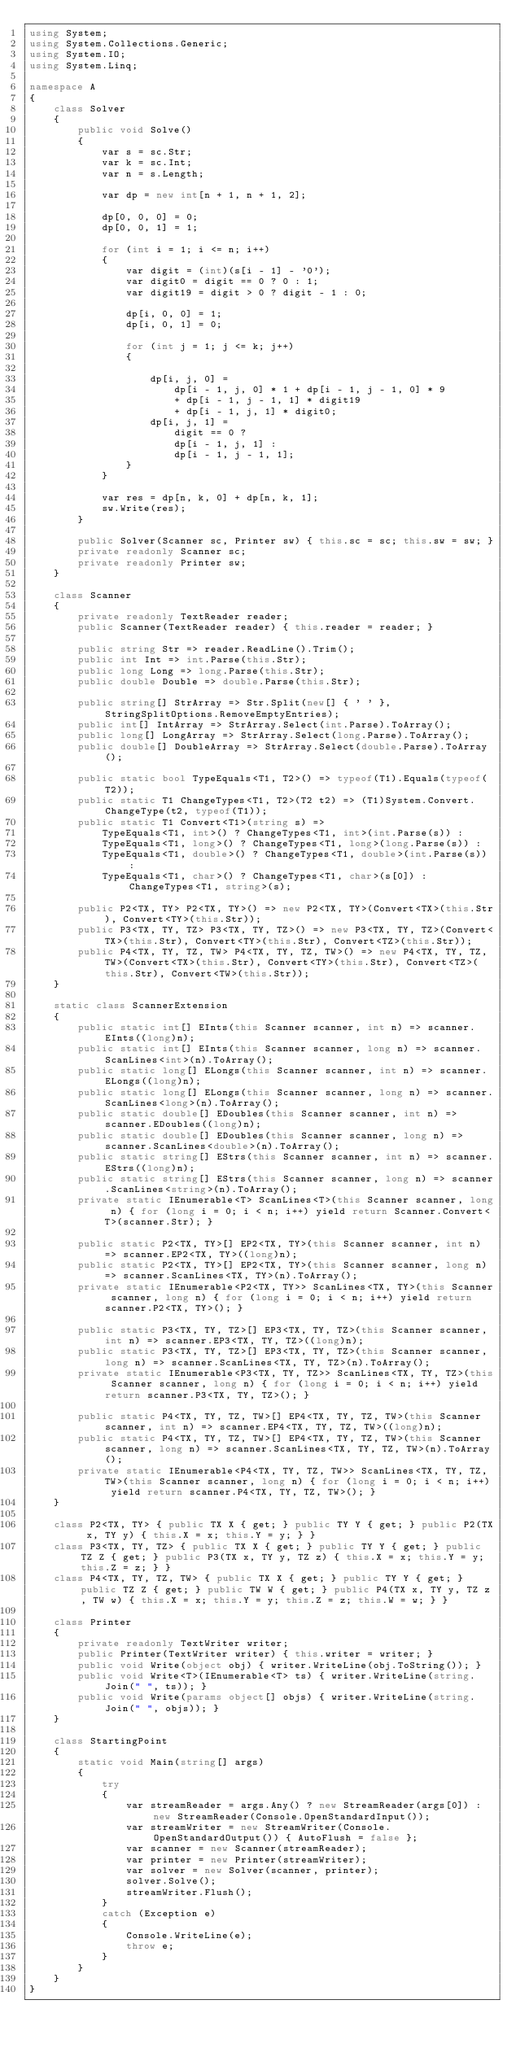<code> <loc_0><loc_0><loc_500><loc_500><_C#_>using System;
using System.Collections.Generic;
using System.IO;
using System.Linq;

namespace A
{
    class Solver
    {
        public void Solve()
        {
            var s = sc.Str;
            var k = sc.Int;
            var n = s.Length;

            var dp = new int[n + 1, n + 1, 2];

            dp[0, 0, 0] = 0;
            dp[0, 0, 1] = 1;

            for (int i = 1; i <= n; i++)
            {
                var digit = (int)(s[i - 1] - '0');
                var digit0 = digit == 0 ? 0 : 1;
                var digit19 = digit > 0 ? digit - 1 : 0;

                dp[i, 0, 0] = 1;
                dp[i, 0, 1] = 0;

                for (int j = 1; j <= k; j++)
                {

                    dp[i, j, 0] =
                        dp[i - 1, j, 0] * 1 + dp[i - 1, j - 1, 0] * 9
                        + dp[i - 1, j - 1, 1] * digit19
                        + dp[i - 1, j, 1] * digit0;
                    dp[i, j, 1] =
                        digit == 0 ?
                        dp[i - 1, j, 1] :
                        dp[i - 1, j - 1, 1];
                }
            }

            var res = dp[n, k, 0] + dp[n, k, 1];
            sw.Write(res);
        }

        public Solver(Scanner sc, Printer sw) { this.sc = sc; this.sw = sw; }
        private readonly Scanner sc;
        private readonly Printer sw;
    }

    class Scanner
    {
        private readonly TextReader reader;
        public Scanner(TextReader reader) { this.reader = reader; }

        public string Str => reader.ReadLine().Trim();
        public int Int => int.Parse(this.Str);
        public long Long => long.Parse(this.Str);
        public double Double => double.Parse(this.Str);

        public string[] StrArray => Str.Split(new[] { ' ' }, StringSplitOptions.RemoveEmptyEntries);
        public int[] IntArray => StrArray.Select(int.Parse).ToArray();
        public long[] LongArray => StrArray.Select(long.Parse).ToArray();
        public double[] DoubleArray => StrArray.Select(double.Parse).ToArray();

        public static bool TypeEquals<T1, T2>() => typeof(T1).Equals(typeof(T2));
        public static T1 ChangeTypes<T1, T2>(T2 t2) => (T1)System.Convert.ChangeType(t2, typeof(T1));
        public static T1 Convert<T1>(string s) =>
            TypeEquals<T1, int>() ? ChangeTypes<T1, int>(int.Parse(s)) :
            TypeEquals<T1, long>() ? ChangeTypes<T1, long>(long.Parse(s)) :
            TypeEquals<T1, double>() ? ChangeTypes<T1, double>(int.Parse(s)) :
            TypeEquals<T1, char>() ? ChangeTypes<T1, char>(s[0]) : ChangeTypes<T1, string>(s);

        public P2<TX, TY> P2<TX, TY>() => new P2<TX, TY>(Convert<TX>(this.Str), Convert<TY>(this.Str));
        public P3<TX, TY, TZ> P3<TX, TY, TZ>() => new P3<TX, TY, TZ>(Convert<TX>(this.Str), Convert<TY>(this.Str), Convert<TZ>(this.Str));
        public P4<TX, TY, TZ, TW> P4<TX, TY, TZ, TW>() => new P4<TX, TY, TZ, TW>(Convert<TX>(this.Str), Convert<TY>(this.Str), Convert<TZ>(this.Str), Convert<TW>(this.Str));
    }

    static class ScannerExtension
    {
        public static int[] EInts(this Scanner scanner, int n) => scanner.EInts((long)n);
        public static int[] EInts(this Scanner scanner, long n) => scanner.ScanLines<int>(n).ToArray();
        public static long[] ELongs(this Scanner scanner, int n) => scanner.ELongs((long)n);
        public static long[] ELongs(this Scanner scanner, long n) => scanner.ScanLines<long>(n).ToArray();
        public static double[] EDoubles(this Scanner scanner, int n) => scanner.EDoubles((long)n);
        public static double[] EDoubles(this Scanner scanner, long n) => scanner.ScanLines<double>(n).ToArray();
        public static string[] EStrs(this Scanner scanner, int n) => scanner.EStrs((long)n);
        public static string[] EStrs(this Scanner scanner, long n) => scanner.ScanLines<string>(n).ToArray();
        private static IEnumerable<T> ScanLines<T>(this Scanner scanner, long n) { for (long i = 0; i < n; i++) yield return Scanner.Convert<T>(scanner.Str); }

        public static P2<TX, TY>[] EP2<TX, TY>(this Scanner scanner, int n) => scanner.EP2<TX, TY>((long)n);
        public static P2<TX, TY>[] EP2<TX, TY>(this Scanner scanner, long n) => scanner.ScanLines<TX, TY>(n).ToArray();
        private static IEnumerable<P2<TX, TY>> ScanLines<TX, TY>(this Scanner scanner, long n) { for (long i = 0; i < n; i++) yield return scanner.P2<TX, TY>(); }

        public static P3<TX, TY, TZ>[] EP3<TX, TY, TZ>(this Scanner scanner, int n) => scanner.EP3<TX, TY, TZ>((long)n);
        public static P3<TX, TY, TZ>[] EP3<TX, TY, TZ>(this Scanner scanner, long n) => scanner.ScanLines<TX, TY, TZ>(n).ToArray();
        private static IEnumerable<P3<TX, TY, TZ>> ScanLines<TX, TY, TZ>(this Scanner scanner, long n) { for (long i = 0; i < n; i++) yield return scanner.P3<TX, TY, TZ>(); }

        public static P4<TX, TY, TZ, TW>[] EP4<TX, TY, TZ, TW>(this Scanner scanner, int n) => scanner.EP4<TX, TY, TZ, TW>((long)n);
        public static P4<TX, TY, TZ, TW>[] EP4<TX, TY, TZ, TW>(this Scanner scanner, long n) => scanner.ScanLines<TX, TY, TZ, TW>(n).ToArray();
        private static IEnumerable<P4<TX, TY, TZ, TW>> ScanLines<TX, TY, TZ, TW>(this Scanner scanner, long n) { for (long i = 0; i < n; i++) yield return scanner.P4<TX, TY, TZ, TW>(); }
    }

    class P2<TX, TY> { public TX X { get; } public TY Y { get; } public P2(TX x, TY y) { this.X = x; this.Y = y; } }
    class P3<TX, TY, TZ> { public TX X { get; } public TY Y { get; } public TZ Z { get; } public P3(TX x, TY y, TZ z) { this.X = x; this.Y = y; this.Z = z; } }
    class P4<TX, TY, TZ, TW> { public TX X { get; } public TY Y { get; } public TZ Z { get; } public TW W { get; } public P4(TX x, TY y, TZ z, TW w) { this.X = x; this.Y = y; this.Z = z; this.W = w; } }

    class Printer
    {
        private readonly TextWriter writer;
        public Printer(TextWriter writer) { this.writer = writer; }
        public void Write(object obj) { writer.WriteLine(obj.ToString()); }
        public void Write<T>(IEnumerable<T> ts) { writer.WriteLine(string.Join(" ", ts)); }
        public void Write(params object[] objs) { writer.WriteLine(string.Join(" ", objs)); }
    }

    class StartingPoint
    {
        static void Main(string[] args)
        {
            try
            {
                var streamReader = args.Any() ? new StreamReader(args[0]) : new StreamReader(Console.OpenStandardInput());
                var streamWriter = new StreamWriter(Console.OpenStandardOutput()) { AutoFlush = false };
                var scanner = new Scanner(streamReader);
                var printer = new Printer(streamWriter);
                var solver = new Solver(scanner, printer);
                solver.Solve();
                streamWriter.Flush();
            }
            catch (Exception e)
            {
                Console.WriteLine(e);
                throw e;
            }
        }
    }
}</code> 